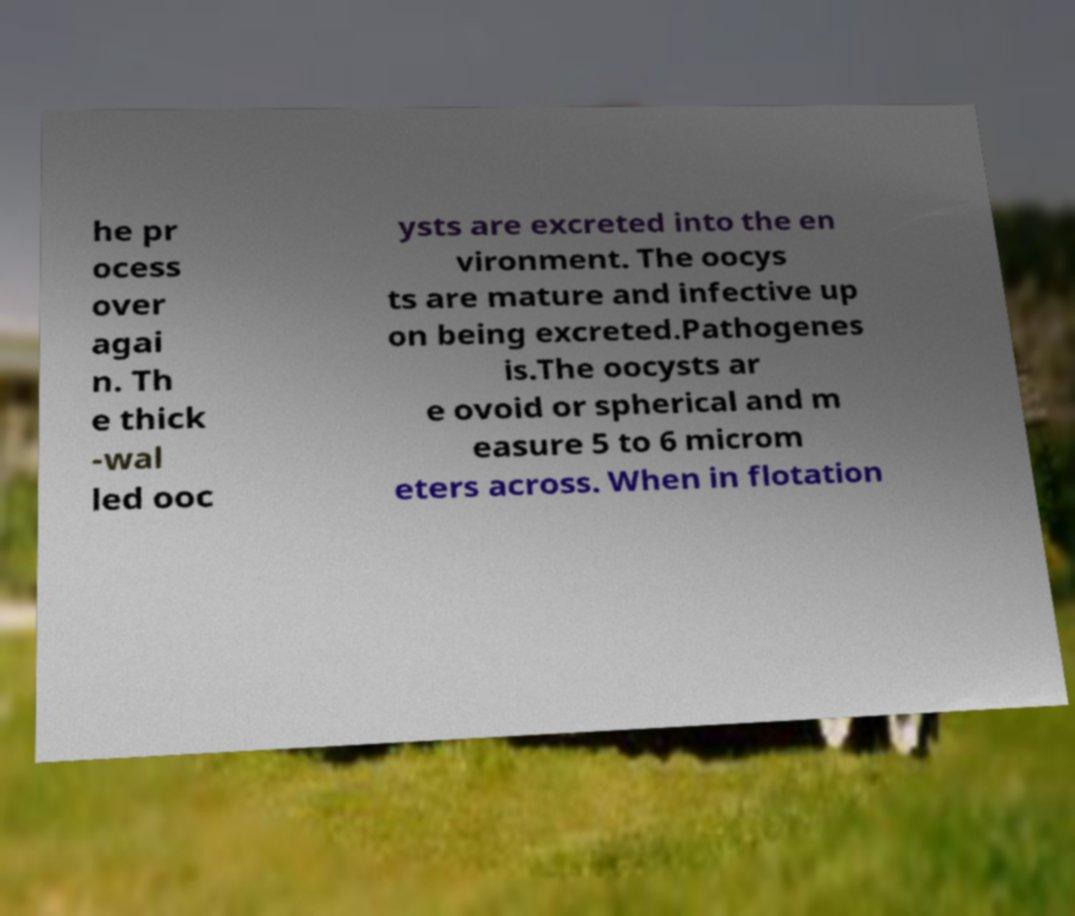Please identify and transcribe the text found in this image. he pr ocess over agai n. Th e thick -wal led ooc ysts are excreted into the en vironment. The oocys ts are mature and infective up on being excreted.Pathogenes is.The oocysts ar e ovoid or spherical and m easure 5 to 6 microm eters across. When in flotation 